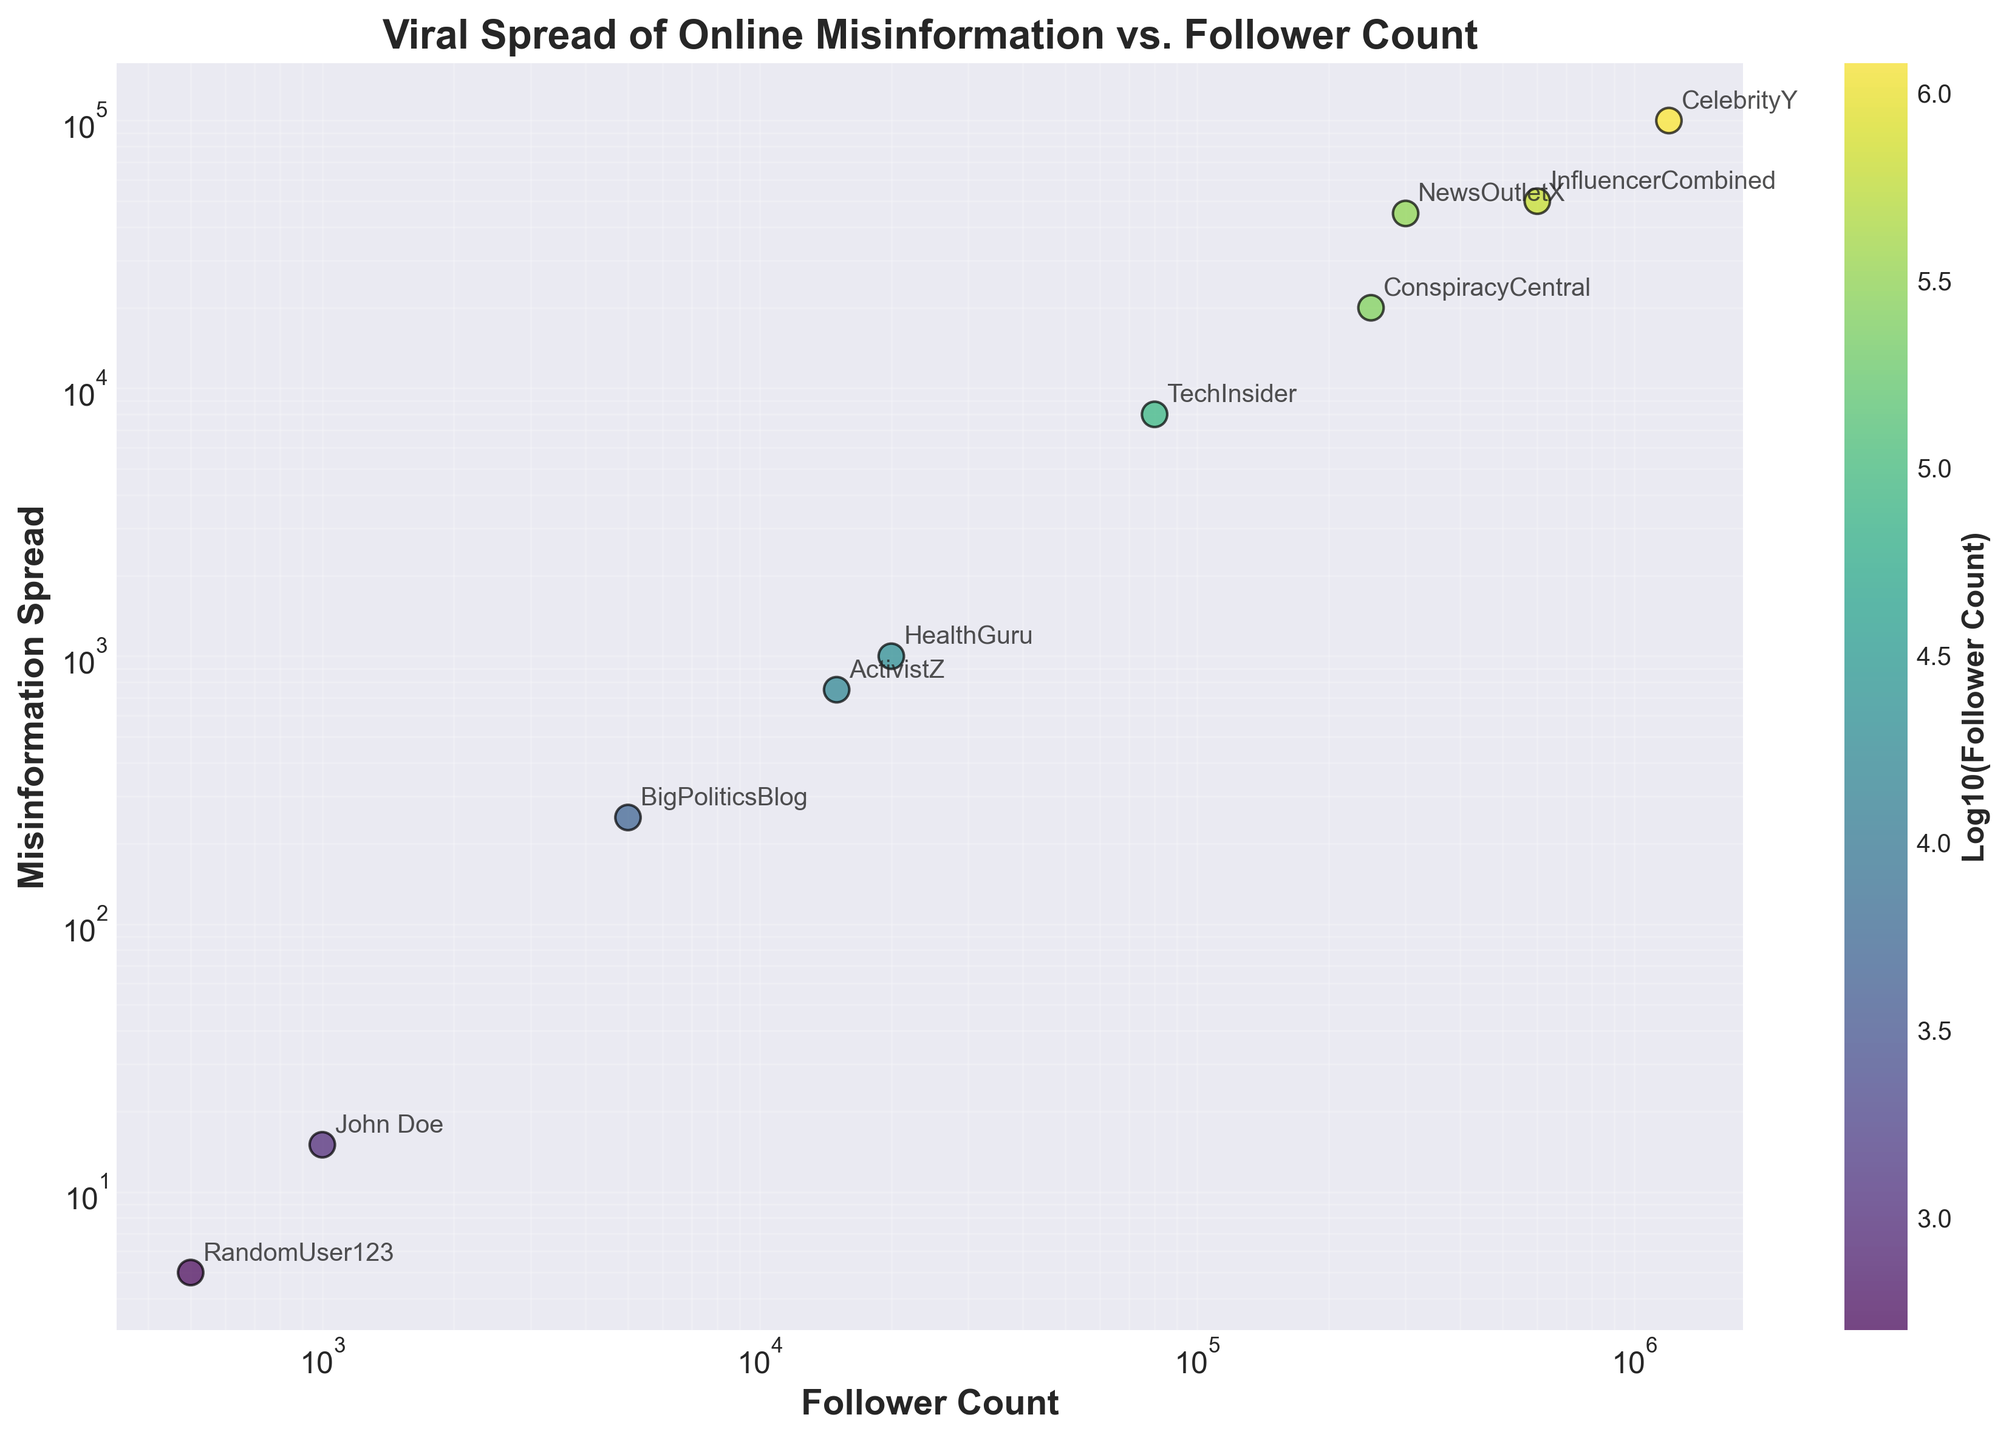What is the title of the figure? The title is displayed at the top center of the figure. It reads "Viral Spread of Online Misinformation vs. Follower Count."
Answer: Viral Spread of Online Misinformation vs. Follower Count How many influencers are presented in the scatter plot? There are ten data points plotted in the figure, each representing one influencer.
Answer: 10 What are the units of the x-axis and y-axis? The x-axis represents "Follower Count," and the y-axis represents "Misinformation Spread." Both axes are in log scale as indicated by the way the data points are spread logarithmically.
Answer: Follower Count and Misinformation Spread Which influencer has the highest follower count? By observing the data points on the x-axis (log scale), "CelebrityY" has the highest follower count, as it is the furthest right on the graph.
Answer: CelebrityY What does the color of the data points represent in the scatter plot? The color of the data points, which shifts from yellow to dark blue, represents the logarithm (log10) of the follower count.
Answer: Log10(Follower Count) Who has a higher misinformation spread, "BigPoliticsBlog" or "HealthGuru"? "BigPoliticsBlog" and "HealthGuru" are compared on the y-axis (log scale). "HealthGuru" spreads more misinformation with 1000 compared to "BigPoliticsBlog's" 250.
Answer: HealthGuru What is the logarithmic relationship between follower count and misinformation spread? The plot uses a log-log scale, suggesting a roughly linear relationship in the log-transformed scales, indicating that misinformation spread increases exponentially with follower count.
Answer: Exponential Comparing "TechInsider" and "NewsOutletX", who has a greater misinformation spread and by how much? "TechInsider" has a misinformation spread of 8000 while "NewsOutletX" has 45000. The difference in spread is 45000 - 8000 = 37000.
Answer: NewsOutletX, 37000 Is there any influencer that breaks the trend of higher follower count correlating with higher misinformation spread? Analyzing the plot, "RandomUser123" stands out because though having a low follower count, it does not follow the clear trend.
Answer: RandomUser123 Between "ActivistZ" and "ConspiracyCentral", who has a higher impact measured by misinformation spread per follower? Calculating the spread per follower: ActivistZ (750/15000 = 0.05) vs. ConspiracyCentral (20000/250000 = 0.08), "ConspiracyCentral" has a higher impact.
Answer: ConspiracyCentral 